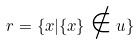<formula> <loc_0><loc_0><loc_500><loc_500>r = \{ x | \{ x \} \notin u \}</formula> 